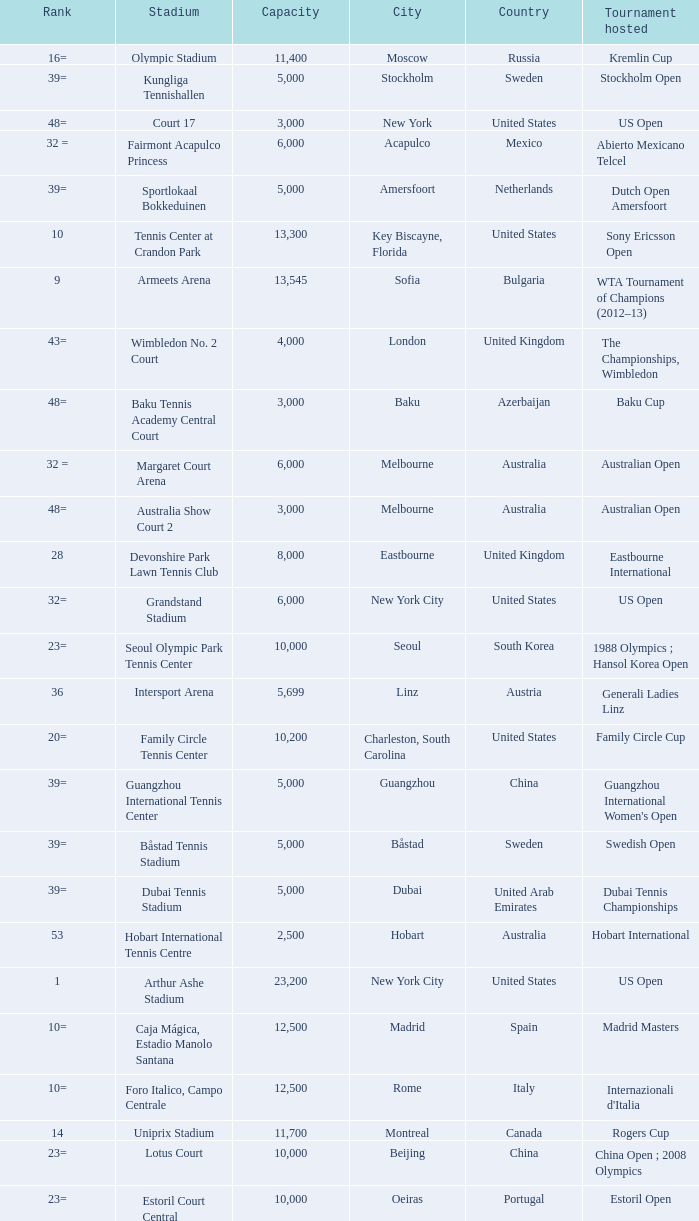What is the average capacity that has switzerland as the country? 6000.0. Parse the full table. {'header': ['Rank', 'Stadium', 'Capacity', 'City', 'Country', 'Tournament hosted'], 'rows': [['16=', 'Olympic Stadium', '11,400', 'Moscow', 'Russia', 'Kremlin Cup'], ['39=', 'Kungliga Tennishallen', '5,000', 'Stockholm', 'Sweden', 'Stockholm Open'], ['48=', 'Court 17', '3,000', 'New York', 'United States', 'US Open'], ['32 =', 'Fairmont Acapulco Princess', '6,000', 'Acapulco', 'Mexico', 'Abierto Mexicano Telcel'], ['39=', 'Sportlokaal Bokkeduinen', '5,000', 'Amersfoort', 'Netherlands', 'Dutch Open Amersfoort'], ['10', 'Tennis Center at Crandon Park', '13,300', 'Key Biscayne, Florida', 'United States', 'Sony Ericsson Open'], ['9', 'Armeets Arena', '13,545', 'Sofia', 'Bulgaria', 'WTA Tournament of Champions (2012–13)'], ['43=', 'Wimbledon No. 2 Court', '4,000', 'London', 'United Kingdom', 'The Championships, Wimbledon'], ['48=', 'Baku Tennis Academy Central Court', '3,000', 'Baku', 'Azerbaijan', 'Baku Cup'], ['32 =', 'Margaret Court Arena', '6,000', 'Melbourne', 'Australia', 'Australian Open'], ['48=', 'Australia Show Court 2', '3,000', 'Melbourne', 'Australia', 'Australian Open'], ['28', 'Devonshire Park Lawn Tennis Club', '8,000', 'Eastbourne', 'United Kingdom', 'Eastbourne International'], ['32=', 'Grandstand Stadium', '6,000', 'New York City', 'United States', 'US Open'], ['23=', 'Seoul Olympic Park Tennis Center', '10,000', 'Seoul', 'South Korea', '1988 Olympics ; Hansol Korea Open'], ['36', 'Intersport Arena', '5,699', 'Linz', 'Austria', 'Generali Ladies Linz'], ['20=', 'Family Circle Tennis Center', '10,200', 'Charleston, South Carolina', 'United States', 'Family Circle Cup'], ['39=', 'Guangzhou International Tennis Center', '5,000', 'Guangzhou', 'China', "Guangzhou International Women's Open"], ['39=', 'Båstad Tennis Stadium', '5,000', 'Båstad', 'Sweden', 'Swedish Open'], ['39=', 'Dubai Tennis Stadium', '5,000', 'Dubai', 'United Arab Emirates', 'Dubai Tennis Championships'], ['53', 'Hobart International Tennis Centre', '2,500', 'Hobart', 'Australia', 'Hobart International'], ['1', 'Arthur Ashe Stadium', '23,200', 'New York City', 'United States', 'US Open'], ['10=', 'Caja Mágica, Estadio Manolo Santana', '12,500', 'Madrid', 'Spain', 'Madrid Masters'], ['10=', 'Foro Italico, Campo Centrale', '12,500', 'Rome', 'Italy', "Internazionali d'Italia"], ['14', 'Uniprix Stadium', '11,700', 'Montreal', 'Canada', 'Rogers Cup'], ['23=', 'Lotus Court', '10,000', 'Beijing', 'China', 'China Open ; 2008 Olympics'], ['23=', 'Estoril Court Central', '10,000', 'Oeiras', 'Portugal', 'Estoril Open'], ['43=', 'Moon Court', '4,000', 'Beijing', 'China', 'China Open'], ['20=', 'Louis Armstrong Stadium', '10,200', 'New York City', 'United States', 'US Open'], ['46', 'Darling Tennis Center', '3,500', 'Las Vegas, Nevada', 'United States', 'Tennis Channel Open'], ['37', 'Pat Rafter Arena', '5,500', 'Brisbane', 'Australia', 'Brisbane International'], ['22', 'Stade Roland Garros - Court Suzanne Lenglen', '10,076', 'Paris', 'France', 'French Open'], ['16=', 'Lindner Family Tennis Center', '11,400', 'Mason, Ohio', 'United States', 'W&SFG Masters'], ['8', 'Rod Laver Arena', '14,820', 'Melbourne', 'Australia', 'Australian Open'], ['45', 'Roland Garros No. 1 Court', '3,805', 'Paris', 'France', 'French Open'], ['4=', 'Wimbledon Centre Court [a ]', '15,000', 'London', 'United Kingdom', 'The Championships, Wimbledon'], ['3', 'Indian Wells Tennis Garden', '16,100', 'Indian Wells, California', 'United States', 'BNP Paribas Open'], ['32=', 'Roy Emerson Arena', '6,000', 'Gstaad', 'Switzerland', 'Allianz Suisse Open Gstaad'], ['29', 'Steffi-Graf-Stadion', '7,000', 'Berlin', 'Germany', 'Qatar Telecom German Open'], ['54=', 'Wimbledon No. 3 Court', '2,000', 'London', 'United Kingdom', 'The Championships, Wimbledon'], ['48=', 'Római Teniszakadémia', '3,000', 'Budapest', 'Hungary', 'Budapest Grand Prix'], ['4=', 'Cullman-Heyman Tennis Center', '15,000', 'New Haven, Connecticut', 'United States', 'New Haven Open at Yale'], ['47', 'ASB Centre', '3,200', 'Auckland', 'New Zealand', 'ASB Classic'], ['27', 'Ariake Coliseum', '9,000', 'Tokyo', 'Japan', 'Japan Open Tennis Championships'], ['23=', 'Tokyo Metropolitan Gymnasium', '10,000', 'Tokyo', 'Japan', 'Toray Pan Pacific Open'], ['18=', 'Hisense Arena', '10,500', 'Melbourne', 'Australia', 'Australian Open'], ['54=', 'National Tennis Center Court 1', '2,000', 'Beijing', 'China', 'China Open'], ['2', 'Sinan Erdem Dome', '16,410', 'Istanbul', 'Turkey', 'WTA Championships'], ['38', 'Racquet Club of Memphis', '5,200', 'Memphis, Tennessee', 'United States', 'Cellular South Cup'], ['48=', 'Australia Show Court 3', '3,000', 'Melbourne', 'Australia', 'Australian Open'], ['10=', 'Rexall Centre', '12,500', 'Toronto', 'Canada', 'Rogers Cup'], ['31', 'Porsche Arena', '6,100', 'Stuttgart', 'Germany', 'Porsche Tennis Grand Prix'], ['30', 'Khalifa International Tennis and Squash Complex', '6,911', 'Doha', 'Qatar', 'Qatar Ladies Open'], ['15', 'Wimbledon No. 1 Court', '11,429', 'London', 'United Kingdom', 'The Championships, Wimbledon'], ['18=', 'Ken Rosewall Arena', '10,500', 'Sydney', 'Australia', 'Medibank International ; 2000 Olympics'], ['4=', 'National Tennis Stadium', '15,000', 'Beijing', 'China', 'China Open ; 2008 Olympics'], ['13', 'Petersburg Sports and Concert Complex', '12,000', 'St. Petersburg', 'Russia', 'St. Petersburg Open'], ['7', 'Stade Roland Garros - Court Philippe Chatrier', '14,911', 'Paris', 'France', 'French Open']]} 